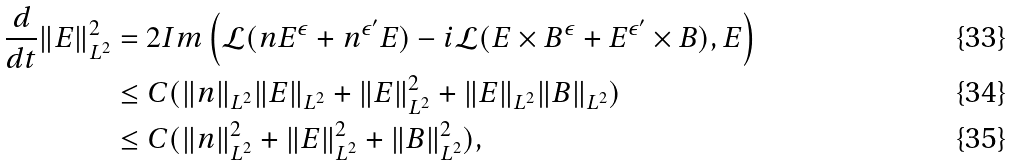<formula> <loc_0><loc_0><loc_500><loc_500>\frac { d } { d t } \| E \| _ { L ^ { 2 } } ^ { 2 } & = 2 I m \left ( \mathcal { L } ( n E ^ { \epsilon } + n ^ { \epsilon ^ { \prime } } E ) - i \mathcal { L } ( E \times B ^ { \epsilon } + E ^ { \epsilon ^ { \prime } } \times B ) , E \right ) \\ & \leq C ( \| n \| _ { L ^ { 2 } } \| E \| _ { L ^ { 2 } } + \| E \| _ { L ^ { 2 } } ^ { 2 } + \| E \| _ { L ^ { 2 } } \| B \| _ { L ^ { 2 } } ) \\ & \leq C ( \| n \| _ { L ^ { 2 } } ^ { 2 } + \| E \| _ { L ^ { 2 } } ^ { 2 } + \| B \| _ { L ^ { 2 } } ^ { 2 } ) ,</formula> 